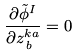<formula> <loc_0><loc_0><loc_500><loc_500>\frac { \partial \tilde { \phi } ^ { I } } { \partial z ^ { k a } _ { \, b } } = 0</formula> 